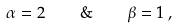<formula> <loc_0><loc_0><loc_500><loc_500>\alpha = 2 \quad \& \quad \beta = 1 \, ,</formula> 